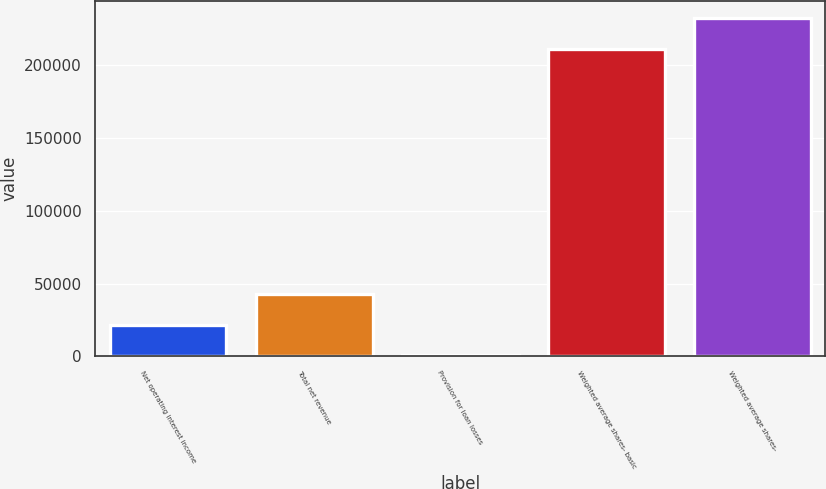Convert chart to OTSL. <chart><loc_0><loc_0><loc_500><loc_500><bar_chart><fcel>Net operating interest income<fcel>Total net revenue<fcel>Provision for loan losses<fcel>Weighted average shares- basic<fcel>Weighted average shares-<nl><fcel>21831.7<fcel>42883.9<fcel>779.4<fcel>211302<fcel>232354<nl></chart> 